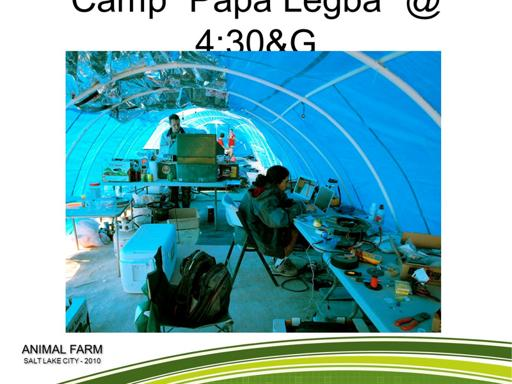What is the purpose of the event mentioned in the image? The event, Animal Farm, as mentioned in the image and held in Salt Lake City in 2010, seems geared towards a tech-oriented or engineering-focused gathering under a large tent structure, possibly aiming to foster innovation, collaboration, or education in technical fields. 